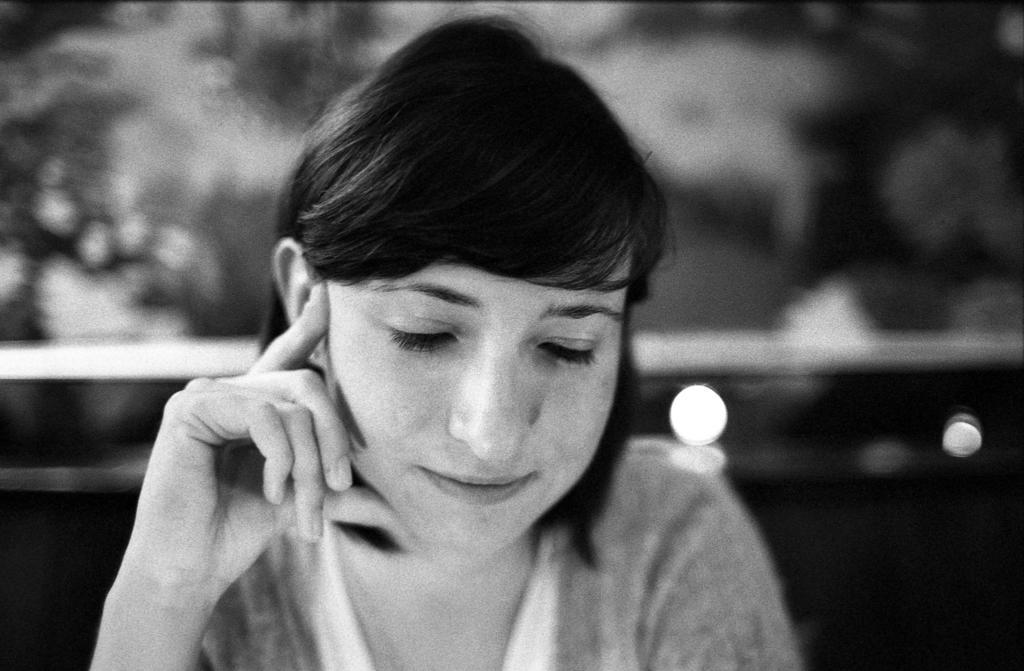Could you give a brief overview of what you see in this image? This is a black and white image. I can see a woman and there is a blurred background. 